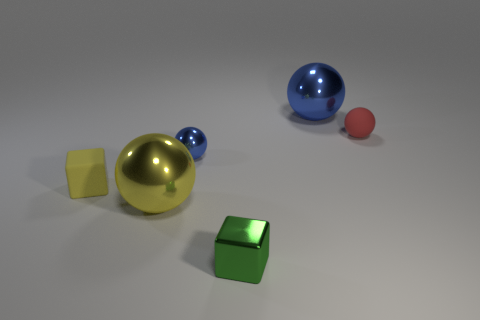Can you describe the arrangement of objects from the largest to smallest? Certainly! Going from largest to smallest, we have the large gold sphere, then the large blue sphere, followed by the medium green cube, the small red sphere, and finally, the tiny yellow cube. 